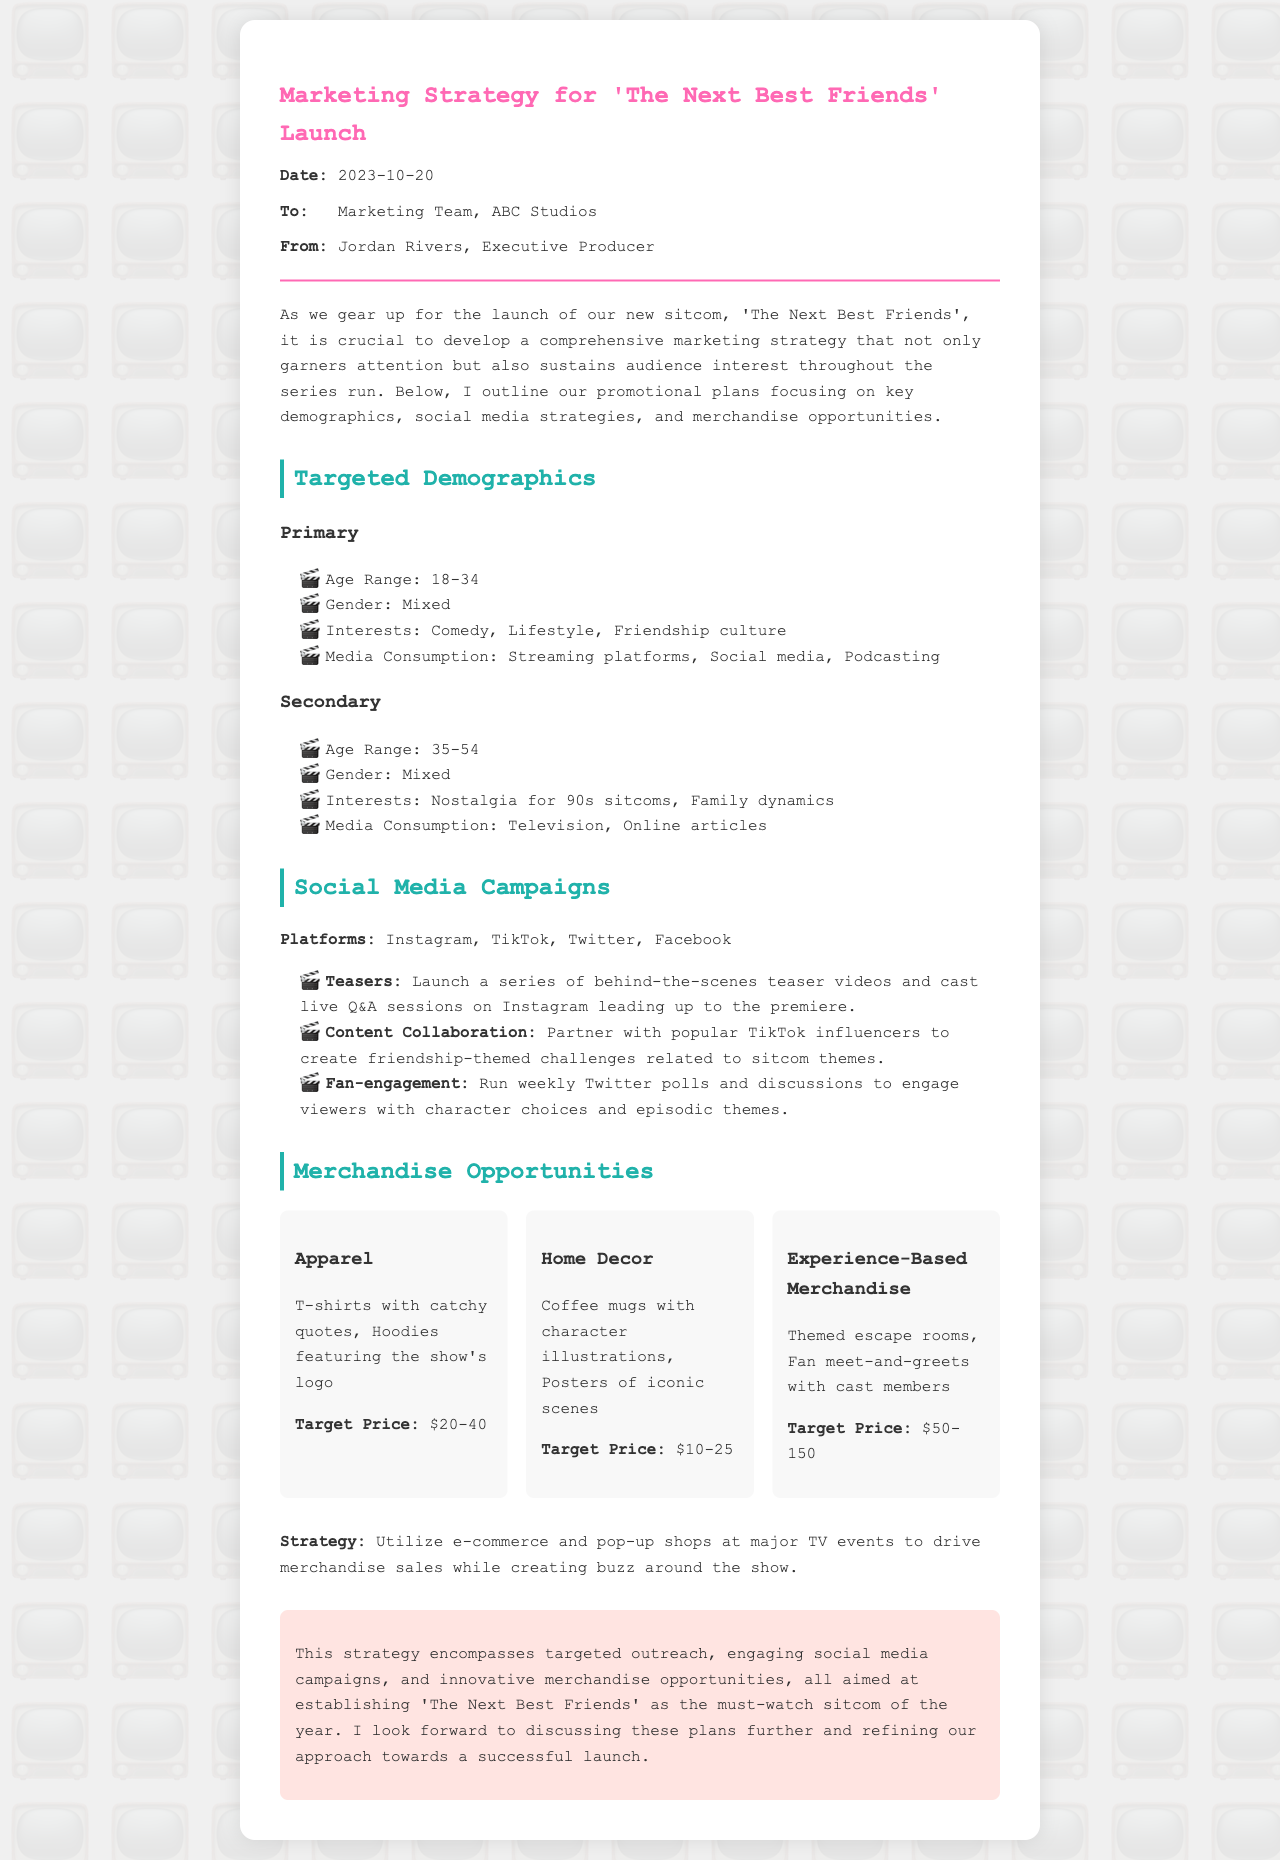what is the date of the letter? The date mentioned in the letter is when it was written, which is indicated clearly at the top.
Answer: 2023-10-20 who is the sender of the letter? The sender's name is listed in the meta information and is noted as the Executive Producer.
Answer: Jordan Rivers what are the primary targeted age demographics? The letter specifies a specific age range for the primary target audience.
Answer: 18-34 what type of merchandise includes coffee mugs? The letter includes categories of merchandise, which specifies what types of items fall under home decor.
Answer: Home Decor which social media platform is mentioned for running weekly polls? The document details specific platforms and activities related to audience engagement.
Answer: Twitter how many merchandise categories are listed? The document outlines different merchandise opportunities, which can be counted for a total.
Answer: 3 what is the target price range for apparel? The letter provides specific price ranges for different types of merchandise offered.
Answer: $20-40 which demographic is described as secondary? The document provides information about two demographic groups, distinguishing them clearly.
Answer: 35-54 what is the purpose of the social media campaigns mentioned? The letter discusses various types of social engagement strategies related to audience involvement.
Answer: Engage viewers 